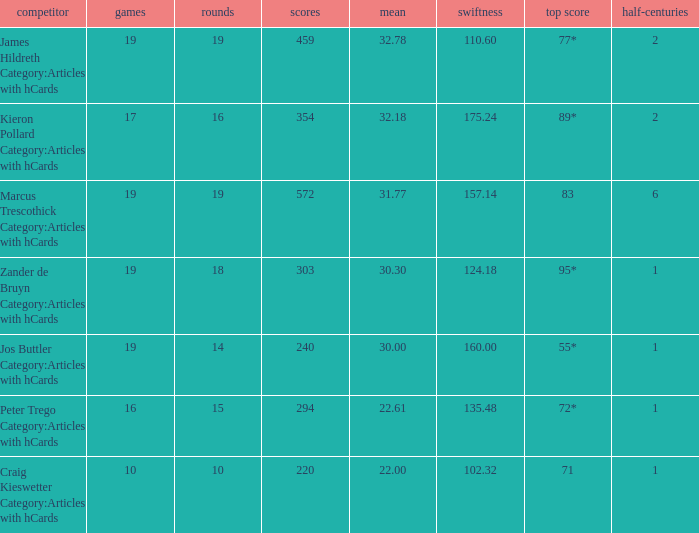What is the highest score for the player with average of 30.00? 55*. 